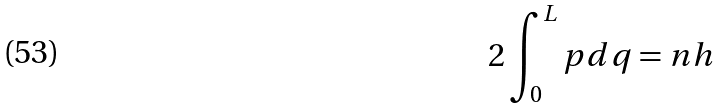<formula> <loc_0><loc_0><loc_500><loc_500>2 \int _ { 0 } ^ { L } p d q = n h</formula> 